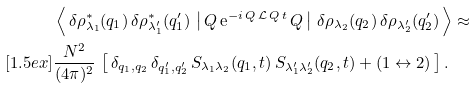<formula> <loc_0><loc_0><loc_500><loc_500>& \left \langle \, \delta \rho ^ { * } _ { \lambda _ { 1 } } ( { q } _ { 1 } ) \, \delta \rho ^ { * } _ { \lambda _ { 1 } ^ { \prime } } ( { q } _ { 1 } ^ { \prime } ) \, \left | \, Q \, \text {e} ^ { - i \, Q \, \mathcal { L } \, Q \, t } \, Q \, \right | \, \delta \rho _ { \lambda _ { 2 } } ( { q } _ { 2 } ) \, \delta \rho _ { \lambda _ { 2 } ^ { \prime } } ( { q } _ { 2 } ^ { \prime } ) \, \right \rangle \approx \\ [ 1 . 5 e x ] & \frac { N ^ { 2 } } { ( 4 \pi ) ^ { 2 } } \, \left [ \, \delta _ { { q } _ { 1 } , { q } _ { 2 } } \, \delta _ { { q } _ { 1 } ^ { \prime } , { q } _ { 2 } ^ { \prime } } \, S _ { \lambda _ { 1 } \lambda _ { 2 } } ( { q } _ { 1 } , t ) \, S _ { \lambda _ { 1 } ^ { \prime } \lambda _ { 2 } ^ { \prime } } ( { q } _ { 2 } , t ) + ( 1 \leftrightarrow 2 ) \, \right ] .</formula> 